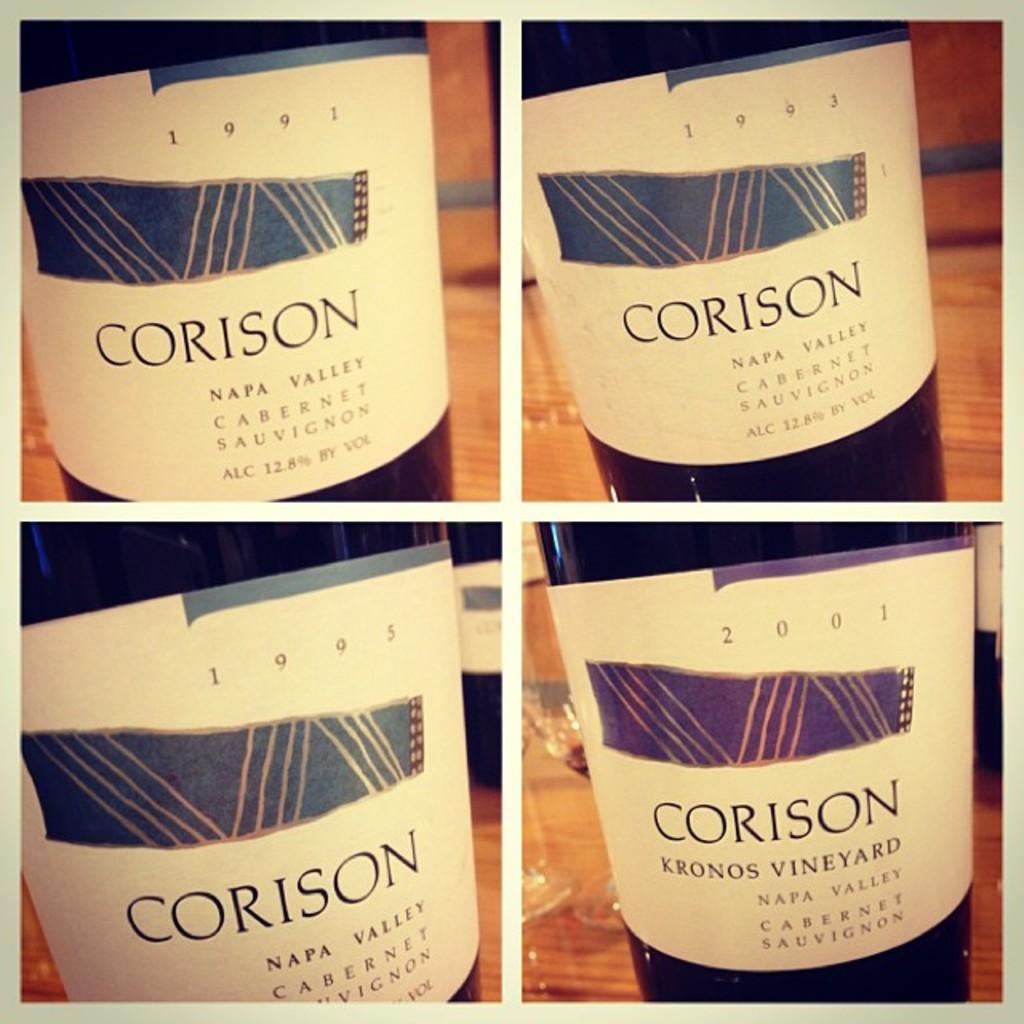<image>
Render a clear and concise summary of the photo. A four pane shot of various years of Corison Napa Valley cabernet sauvignon from 1993 to 2001. 